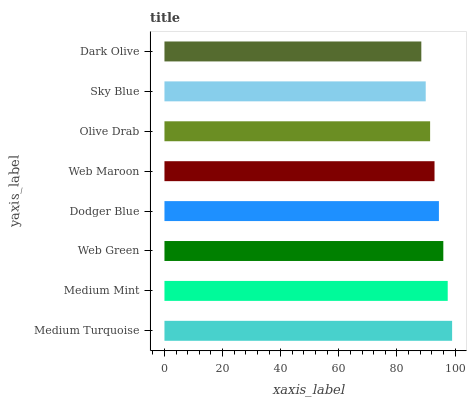Is Dark Olive the minimum?
Answer yes or no. Yes. Is Medium Turquoise the maximum?
Answer yes or no. Yes. Is Medium Mint the minimum?
Answer yes or no. No. Is Medium Mint the maximum?
Answer yes or no. No. Is Medium Turquoise greater than Medium Mint?
Answer yes or no. Yes. Is Medium Mint less than Medium Turquoise?
Answer yes or no. Yes. Is Medium Mint greater than Medium Turquoise?
Answer yes or no. No. Is Medium Turquoise less than Medium Mint?
Answer yes or no. No. Is Dodger Blue the high median?
Answer yes or no. Yes. Is Web Maroon the low median?
Answer yes or no. Yes. Is Dark Olive the high median?
Answer yes or no. No. Is Olive Drab the low median?
Answer yes or no. No. 